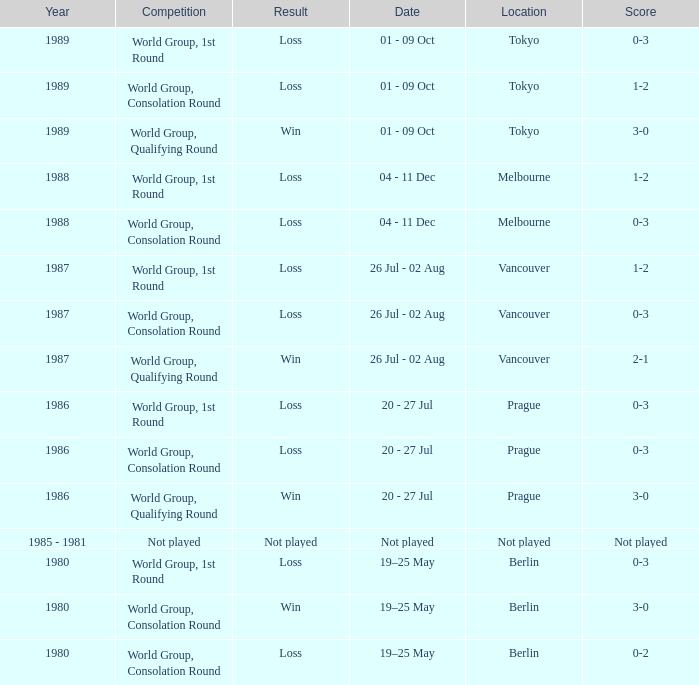What is the score when the result is loss, the year is 1980 and the competition is world group, consolation round? 0-2. 